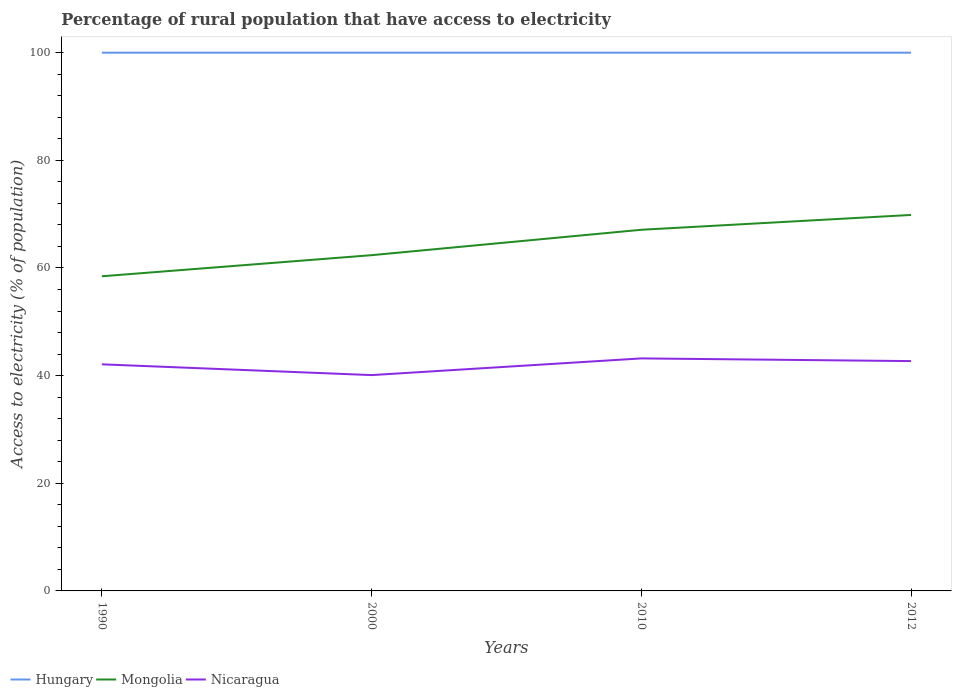Does the line corresponding to Nicaragua intersect with the line corresponding to Hungary?
Your answer should be compact. No. Across all years, what is the maximum percentage of rural population that have access to electricity in Nicaragua?
Offer a very short reply. 40.1. In which year was the percentage of rural population that have access to electricity in Hungary maximum?
Your answer should be very brief. 1990. What is the total percentage of rural population that have access to electricity in Nicaragua in the graph?
Ensure brevity in your answer.  -2.6. What is the difference between the highest and the second highest percentage of rural population that have access to electricity in Nicaragua?
Keep it short and to the point. 3.1. What is the difference between the highest and the lowest percentage of rural population that have access to electricity in Hungary?
Provide a short and direct response. 0. How many years are there in the graph?
Provide a succinct answer. 4. What is the difference between two consecutive major ticks on the Y-axis?
Your response must be concise. 20. Are the values on the major ticks of Y-axis written in scientific E-notation?
Your answer should be very brief. No. Does the graph contain grids?
Your answer should be compact. No. What is the title of the graph?
Offer a very short reply. Percentage of rural population that have access to electricity. Does "Myanmar" appear as one of the legend labels in the graph?
Keep it short and to the point. No. What is the label or title of the Y-axis?
Ensure brevity in your answer.  Access to electricity (% of population). What is the Access to electricity (% of population) of Mongolia in 1990?
Keep it short and to the point. 58.46. What is the Access to electricity (% of population) in Nicaragua in 1990?
Your answer should be compact. 42.1. What is the Access to electricity (% of population) in Mongolia in 2000?
Provide a succinct answer. 62.38. What is the Access to electricity (% of population) of Nicaragua in 2000?
Give a very brief answer. 40.1. What is the Access to electricity (% of population) in Hungary in 2010?
Offer a very short reply. 100. What is the Access to electricity (% of population) in Mongolia in 2010?
Your answer should be very brief. 67.1. What is the Access to electricity (% of population) of Nicaragua in 2010?
Your answer should be compact. 43.2. What is the Access to electricity (% of population) of Hungary in 2012?
Provide a short and direct response. 100. What is the Access to electricity (% of population) in Mongolia in 2012?
Keep it short and to the point. 69.85. What is the Access to electricity (% of population) in Nicaragua in 2012?
Give a very brief answer. 42.7. Across all years, what is the maximum Access to electricity (% of population) in Hungary?
Provide a short and direct response. 100. Across all years, what is the maximum Access to electricity (% of population) of Mongolia?
Your answer should be compact. 69.85. Across all years, what is the maximum Access to electricity (% of population) in Nicaragua?
Your response must be concise. 43.2. Across all years, what is the minimum Access to electricity (% of population) in Mongolia?
Your answer should be compact. 58.46. Across all years, what is the minimum Access to electricity (% of population) of Nicaragua?
Your response must be concise. 40.1. What is the total Access to electricity (% of population) in Hungary in the graph?
Offer a terse response. 400. What is the total Access to electricity (% of population) of Mongolia in the graph?
Make the answer very short. 257.8. What is the total Access to electricity (% of population) of Nicaragua in the graph?
Keep it short and to the point. 168.1. What is the difference between the Access to electricity (% of population) of Mongolia in 1990 and that in 2000?
Ensure brevity in your answer.  -3.92. What is the difference between the Access to electricity (% of population) in Mongolia in 1990 and that in 2010?
Make the answer very short. -8.64. What is the difference between the Access to electricity (% of population) of Nicaragua in 1990 and that in 2010?
Ensure brevity in your answer.  -1.1. What is the difference between the Access to electricity (% of population) in Mongolia in 1990 and that in 2012?
Provide a succinct answer. -11.39. What is the difference between the Access to electricity (% of population) of Mongolia in 2000 and that in 2010?
Provide a succinct answer. -4.72. What is the difference between the Access to electricity (% of population) in Hungary in 2000 and that in 2012?
Provide a short and direct response. 0. What is the difference between the Access to electricity (% of population) of Mongolia in 2000 and that in 2012?
Provide a short and direct response. -7.47. What is the difference between the Access to electricity (% of population) in Nicaragua in 2000 and that in 2012?
Keep it short and to the point. -2.6. What is the difference between the Access to electricity (% of population) of Hungary in 2010 and that in 2012?
Provide a short and direct response. 0. What is the difference between the Access to electricity (% of population) in Mongolia in 2010 and that in 2012?
Your response must be concise. -2.75. What is the difference between the Access to electricity (% of population) in Nicaragua in 2010 and that in 2012?
Offer a very short reply. 0.5. What is the difference between the Access to electricity (% of population) of Hungary in 1990 and the Access to electricity (% of population) of Mongolia in 2000?
Keep it short and to the point. 37.62. What is the difference between the Access to electricity (% of population) of Hungary in 1990 and the Access to electricity (% of population) of Nicaragua in 2000?
Provide a succinct answer. 59.9. What is the difference between the Access to electricity (% of population) in Mongolia in 1990 and the Access to electricity (% of population) in Nicaragua in 2000?
Provide a short and direct response. 18.36. What is the difference between the Access to electricity (% of population) of Hungary in 1990 and the Access to electricity (% of population) of Mongolia in 2010?
Keep it short and to the point. 32.9. What is the difference between the Access to electricity (% of population) in Hungary in 1990 and the Access to electricity (% of population) in Nicaragua in 2010?
Offer a very short reply. 56.8. What is the difference between the Access to electricity (% of population) of Mongolia in 1990 and the Access to electricity (% of population) of Nicaragua in 2010?
Provide a short and direct response. 15.26. What is the difference between the Access to electricity (% of population) of Hungary in 1990 and the Access to electricity (% of population) of Mongolia in 2012?
Make the answer very short. 30.15. What is the difference between the Access to electricity (% of population) of Hungary in 1990 and the Access to electricity (% of population) of Nicaragua in 2012?
Keep it short and to the point. 57.3. What is the difference between the Access to electricity (% of population) in Mongolia in 1990 and the Access to electricity (% of population) in Nicaragua in 2012?
Offer a very short reply. 15.76. What is the difference between the Access to electricity (% of population) in Hungary in 2000 and the Access to electricity (% of population) in Mongolia in 2010?
Ensure brevity in your answer.  32.9. What is the difference between the Access to electricity (% of population) of Hungary in 2000 and the Access to electricity (% of population) of Nicaragua in 2010?
Give a very brief answer. 56.8. What is the difference between the Access to electricity (% of population) in Mongolia in 2000 and the Access to electricity (% of population) in Nicaragua in 2010?
Give a very brief answer. 19.18. What is the difference between the Access to electricity (% of population) of Hungary in 2000 and the Access to electricity (% of population) of Mongolia in 2012?
Give a very brief answer. 30.15. What is the difference between the Access to electricity (% of population) in Hungary in 2000 and the Access to electricity (% of population) in Nicaragua in 2012?
Provide a short and direct response. 57.3. What is the difference between the Access to electricity (% of population) in Mongolia in 2000 and the Access to electricity (% of population) in Nicaragua in 2012?
Keep it short and to the point. 19.68. What is the difference between the Access to electricity (% of population) in Hungary in 2010 and the Access to electricity (% of population) in Mongolia in 2012?
Provide a succinct answer. 30.15. What is the difference between the Access to electricity (% of population) in Hungary in 2010 and the Access to electricity (% of population) in Nicaragua in 2012?
Make the answer very short. 57.3. What is the difference between the Access to electricity (% of population) of Mongolia in 2010 and the Access to electricity (% of population) of Nicaragua in 2012?
Make the answer very short. 24.4. What is the average Access to electricity (% of population) of Mongolia per year?
Make the answer very short. 64.45. What is the average Access to electricity (% of population) of Nicaragua per year?
Provide a succinct answer. 42.02. In the year 1990, what is the difference between the Access to electricity (% of population) in Hungary and Access to electricity (% of population) in Mongolia?
Ensure brevity in your answer.  41.54. In the year 1990, what is the difference between the Access to electricity (% of population) in Hungary and Access to electricity (% of population) in Nicaragua?
Offer a very short reply. 57.9. In the year 1990, what is the difference between the Access to electricity (% of population) of Mongolia and Access to electricity (% of population) of Nicaragua?
Keep it short and to the point. 16.36. In the year 2000, what is the difference between the Access to electricity (% of population) of Hungary and Access to electricity (% of population) of Mongolia?
Provide a short and direct response. 37.62. In the year 2000, what is the difference between the Access to electricity (% of population) of Hungary and Access to electricity (% of population) of Nicaragua?
Your response must be concise. 59.9. In the year 2000, what is the difference between the Access to electricity (% of population) in Mongolia and Access to electricity (% of population) in Nicaragua?
Your answer should be compact. 22.28. In the year 2010, what is the difference between the Access to electricity (% of population) in Hungary and Access to electricity (% of population) in Mongolia?
Your response must be concise. 32.9. In the year 2010, what is the difference between the Access to electricity (% of population) of Hungary and Access to electricity (% of population) of Nicaragua?
Your answer should be very brief. 56.8. In the year 2010, what is the difference between the Access to electricity (% of population) of Mongolia and Access to electricity (% of population) of Nicaragua?
Your answer should be compact. 23.9. In the year 2012, what is the difference between the Access to electricity (% of population) of Hungary and Access to electricity (% of population) of Mongolia?
Provide a short and direct response. 30.15. In the year 2012, what is the difference between the Access to electricity (% of population) of Hungary and Access to electricity (% of population) of Nicaragua?
Offer a terse response. 57.3. In the year 2012, what is the difference between the Access to electricity (% of population) of Mongolia and Access to electricity (% of population) of Nicaragua?
Keep it short and to the point. 27.15. What is the ratio of the Access to electricity (% of population) in Hungary in 1990 to that in 2000?
Your answer should be very brief. 1. What is the ratio of the Access to electricity (% of population) in Mongolia in 1990 to that in 2000?
Your answer should be very brief. 0.94. What is the ratio of the Access to electricity (% of population) of Nicaragua in 1990 to that in 2000?
Offer a terse response. 1.05. What is the ratio of the Access to electricity (% of population) of Hungary in 1990 to that in 2010?
Ensure brevity in your answer.  1. What is the ratio of the Access to electricity (% of population) in Mongolia in 1990 to that in 2010?
Provide a short and direct response. 0.87. What is the ratio of the Access to electricity (% of population) in Nicaragua in 1990 to that in 2010?
Make the answer very short. 0.97. What is the ratio of the Access to electricity (% of population) in Mongolia in 1990 to that in 2012?
Keep it short and to the point. 0.84. What is the ratio of the Access to electricity (% of population) in Nicaragua in 1990 to that in 2012?
Provide a short and direct response. 0.99. What is the ratio of the Access to electricity (% of population) in Mongolia in 2000 to that in 2010?
Give a very brief answer. 0.93. What is the ratio of the Access to electricity (% of population) of Nicaragua in 2000 to that in 2010?
Your answer should be very brief. 0.93. What is the ratio of the Access to electricity (% of population) in Hungary in 2000 to that in 2012?
Your answer should be compact. 1. What is the ratio of the Access to electricity (% of population) of Mongolia in 2000 to that in 2012?
Offer a very short reply. 0.89. What is the ratio of the Access to electricity (% of population) in Nicaragua in 2000 to that in 2012?
Make the answer very short. 0.94. What is the ratio of the Access to electricity (% of population) in Hungary in 2010 to that in 2012?
Your response must be concise. 1. What is the ratio of the Access to electricity (% of population) of Mongolia in 2010 to that in 2012?
Your answer should be compact. 0.96. What is the ratio of the Access to electricity (% of population) of Nicaragua in 2010 to that in 2012?
Give a very brief answer. 1.01. What is the difference between the highest and the second highest Access to electricity (% of population) in Hungary?
Your response must be concise. 0. What is the difference between the highest and the second highest Access to electricity (% of population) of Mongolia?
Give a very brief answer. 2.75. What is the difference between the highest and the second highest Access to electricity (% of population) in Nicaragua?
Your response must be concise. 0.5. What is the difference between the highest and the lowest Access to electricity (% of population) of Hungary?
Ensure brevity in your answer.  0. What is the difference between the highest and the lowest Access to electricity (% of population) in Mongolia?
Keep it short and to the point. 11.39. 